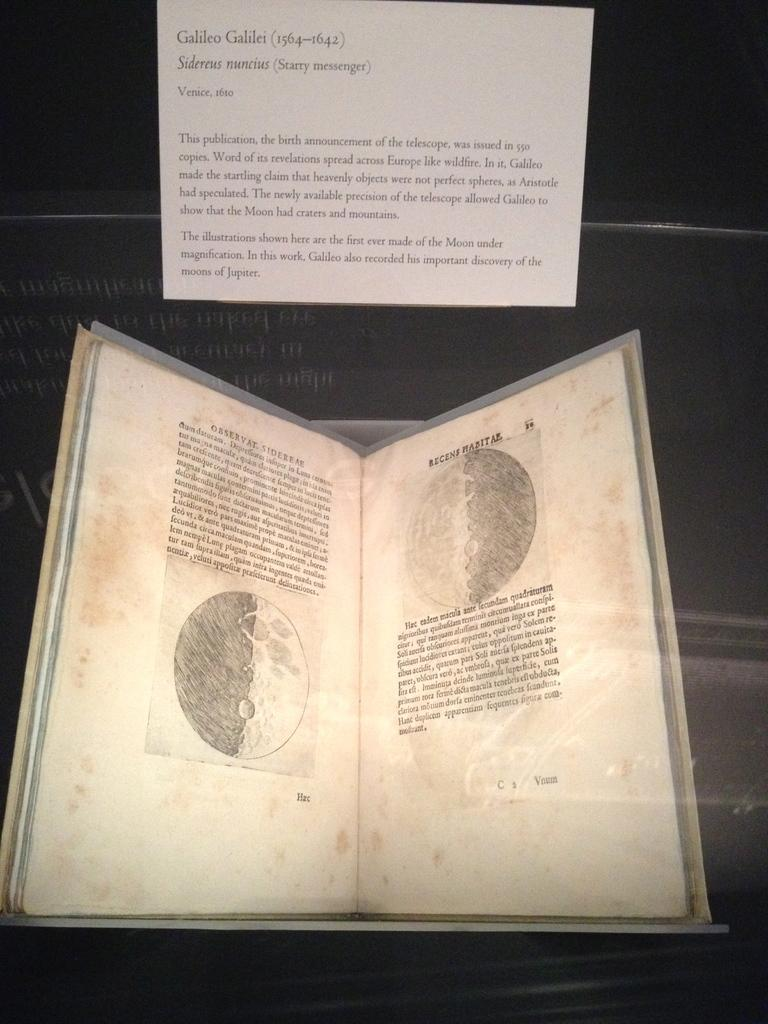<image>
Give a short and clear explanation of the subsequent image. Book about Galileo that includes pictures and details 